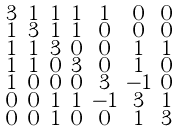Convert formula to latex. <formula><loc_0><loc_0><loc_500><loc_500>\begin{smallmatrix} 3 & 1 & 1 & 1 & 1 & 0 & 0 \\ 1 & 3 & 1 & 1 & 0 & 0 & 0 \\ 1 & 1 & 3 & 0 & 0 & 1 & 1 \\ 1 & 1 & 0 & 3 & 0 & 1 & 0 \\ 1 & 0 & 0 & 0 & 3 & - 1 & 0 \\ 0 & 0 & 1 & 1 & - 1 & 3 & 1 \\ 0 & 0 & 1 & 0 & 0 & 1 & 3 \end{smallmatrix}</formula> 